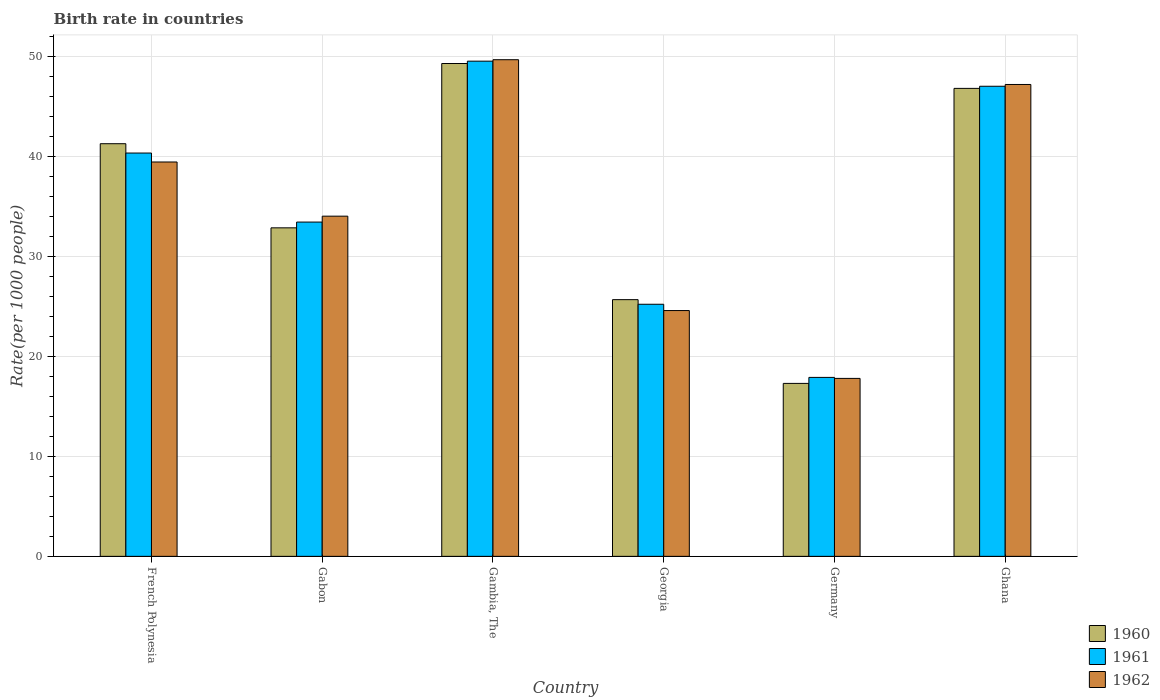How many different coloured bars are there?
Ensure brevity in your answer.  3. How many groups of bars are there?
Your answer should be very brief. 6. Are the number of bars per tick equal to the number of legend labels?
Offer a very short reply. Yes. How many bars are there on the 3rd tick from the right?
Your answer should be very brief. 3. What is the label of the 2nd group of bars from the left?
Offer a very short reply. Gabon. In how many cases, is the number of bars for a given country not equal to the number of legend labels?
Provide a short and direct response. 0. What is the birth rate in 1961 in Gambia, The?
Make the answer very short. 49.53. Across all countries, what is the maximum birth rate in 1960?
Offer a terse response. 49.3. In which country was the birth rate in 1960 maximum?
Your response must be concise. Gambia, The. In which country was the birth rate in 1961 minimum?
Make the answer very short. Germany. What is the total birth rate in 1962 in the graph?
Give a very brief answer. 212.73. What is the difference between the birth rate in 1961 in French Polynesia and that in Georgia?
Provide a short and direct response. 15.13. What is the difference between the birth rate in 1960 in Georgia and the birth rate in 1961 in Gambia, The?
Your answer should be compact. -23.86. What is the average birth rate in 1962 per country?
Give a very brief answer. 35.46. What is the difference between the birth rate of/in 1960 and birth rate of/in 1962 in Germany?
Keep it short and to the point. -0.5. What is the ratio of the birth rate in 1961 in Gabon to that in Gambia, The?
Offer a terse response. 0.68. What is the difference between the highest and the second highest birth rate in 1962?
Your answer should be very brief. 10.23. What is the difference between the highest and the lowest birth rate in 1962?
Give a very brief answer. 31.88. Is the sum of the birth rate in 1961 in Gambia, The and Georgia greater than the maximum birth rate in 1962 across all countries?
Your response must be concise. Yes. What does the 2nd bar from the left in Gambia, The represents?
Your response must be concise. 1961. Is it the case that in every country, the sum of the birth rate in 1962 and birth rate in 1961 is greater than the birth rate in 1960?
Your answer should be very brief. Yes. Are all the bars in the graph horizontal?
Provide a short and direct response. No. Are the values on the major ticks of Y-axis written in scientific E-notation?
Make the answer very short. No. Does the graph contain grids?
Your response must be concise. Yes. How many legend labels are there?
Give a very brief answer. 3. What is the title of the graph?
Provide a short and direct response. Birth rate in countries. What is the label or title of the Y-axis?
Provide a succinct answer. Rate(per 1000 people). What is the Rate(per 1000 people) of 1960 in French Polynesia?
Your response must be concise. 41.27. What is the Rate(per 1000 people) in 1961 in French Polynesia?
Ensure brevity in your answer.  40.34. What is the Rate(per 1000 people) of 1962 in French Polynesia?
Provide a succinct answer. 39.45. What is the Rate(per 1000 people) of 1960 in Gabon?
Your response must be concise. 32.86. What is the Rate(per 1000 people) of 1961 in Gabon?
Your response must be concise. 33.44. What is the Rate(per 1000 people) in 1962 in Gabon?
Offer a terse response. 34.03. What is the Rate(per 1000 people) in 1960 in Gambia, The?
Provide a short and direct response. 49.3. What is the Rate(per 1000 people) in 1961 in Gambia, The?
Your response must be concise. 49.53. What is the Rate(per 1000 people) of 1962 in Gambia, The?
Your answer should be very brief. 49.68. What is the Rate(per 1000 people) of 1960 in Georgia?
Give a very brief answer. 25.68. What is the Rate(per 1000 people) of 1961 in Georgia?
Give a very brief answer. 25.22. What is the Rate(per 1000 people) of 1962 in Georgia?
Give a very brief answer. 24.59. What is the Rate(per 1000 people) of 1961 in Germany?
Keep it short and to the point. 17.9. What is the Rate(per 1000 people) of 1962 in Germany?
Keep it short and to the point. 17.8. What is the Rate(per 1000 people) of 1960 in Ghana?
Offer a very short reply. 46.81. What is the Rate(per 1000 people) of 1961 in Ghana?
Your answer should be compact. 47.02. What is the Rate(per 1000 people) of 1962 in Ghana?
Offer a terse response. 47.2. Across all countries, what is the maximum Rate(per 1000 people) in 1960?
Provide a short and direct response. 49.3. Across all countries, what is the maximum Rate(per 1000 people) of 1961?
Give a very brief answer. 49.53. Across all countries, what is the maximum Rate(per 1000 people) of 1962?
Give a very brief answer. 49.68. Across all countries, what is the minimum Rate(per 1000 people) of 1961?
Your answer should be very brief. 17.9. What is the total Rate(per 1000 people) of 1960 in the graph?
Keep it short and to the point. 213.22. What is the total Rate(per 1000 people) in 1961 in the graph?
Make the answer very short. 213.45. What is the total Rate(per 1000 people) of 1962 in the graph?
Offer a terse response. 212.73. What is the difference between the Rate(per 1000 people) in 1960 in French Polynesia and that in Gabon?
Provide a short and direct response. 8.41. What is the difference between the Rate(per 1000 people) in 1961 in French Polynesia and that in Gabon?
Ensure brevity in your answer.  6.91. What is the difference between the Rate(per 1000 people) of 1962 in French Polynesia and that in Gabon?
Your answer should be compact. 5.42. What is the difference between the Rate(per 1000 people) in 1960 in French Polynesia and that in Gambia, The?
Your answer should be very brief. -8.02. What is the difference between the Rate(per 1000 people) of 1961 in French Polynesia and that in Gambia, The?
Keep it short and to the point. -9.19. What is the difference between the Rate(per 1000 people) of 1962 in French Polynesia and that in Gambia, The?
Keep it short and to the point. -10.23. What is the difference between the Rate(per 1000 people) in 1960 in French Polynesia and that in Georgia?
Offer a terse response. 15.6. What is the difference between the Rate(per 1000 people) in 1961 in French Polynesia and that in Georgia?
Give a very brief answer. 15.13. What is the difference between the Rate(per 1000 people) in 1962 in French Polynesia and that in Georgia?
Keep it short and to the point. 14.86. What is the difference between the Rate(per 1000 people) of 1960 in French Polynesia and that in Germany?
Make the answer very short. 23.98. What is the difference between the Rate(per 1000 people) in 1961 in French Polynesia and that in Germany?
Offer a terse response. 22.44. What is the difference between the Rate(per 1000 people) in 1962 in French Polynesia and that in Germany?
Offer a very short reply. 21.64. What is the difference between the Rate(per 1000 people) of 1960 in French Polynesia and that in Ghana?
Make the answer very short. -5.53. What is the difference between the Rate(per 1000 people) in 1961 in French Polynesia and that in Ghana?
Keep it short and to the point. -6.68. What is the difference between the Rate(per 1000 people) in 1962 in French Polynesia and that in Ghana?
Your answer should be very brief. -7.75. What is the difference between the Rate(per 1000 people) in 1960 in Gabon and that in Gambia, The?
Your response must be concise. -16.44. What is the difference between the Rate(per 1000 people) in 1961 in Gabon and that in Gambia, The?
Offer a very short reply. -16.09. What is the difference between the Rate(per 1000 people) in 1962 in Gabon and that in Gambia, The?
Keep it short and to the point. -15.65. What is the difference between the Rate(per 1000 people) in 1960 in Gabon and that in Georgia?
Ensure brevity in your answer.  7.18. What is the difference between the Rate(per 1000 people) in 1961 in Gabon and that in Georgia?
Provide a succinct answer. 8.22. What is the difference between the Rate(per 1000 people) of 1962 in Gabon and that in Georgia?
Give a very brief answer. 9.44. What is the difference between the Rate(per 1000 people) in 1960 in Gabon and that in Germany?
Make the answer very short. 15.56. What is the difference between the Rate(per 1000 people) in 1961 in Gabon and that in Germany?
Your answer should be compact. 15.54. What is the difference between the Rate(per 1000 people) of 1962 in Gabon and that in Germany?
Keep it short and to the point. 16.23. What is the difference between the Rate(per 1000 people) in 1960 in Gabon and that in Ghana?
Ensure brevity in your answer.  -13.95. What is the difference between the Rate(per 1000 people) of 1961 in Gabon and that in Ghana?
Ensure brevity in your answer.  -13.59. What is the difference between the Rate(per 1000 people) of 1962 in Gabon and that in Ghana?
Offer a terse response. -13.17. What is the difference between the Rate(per 1000 people) of 1960 in Gambia, The and that in Georgia?
Offer a terse response. 23.62. What is the difference between the Rate(per 1000 people) in 1961 in Gambia, The and that in Georgia?
Your response must be concise. 24.32. What is the difference between the Rate(per 1000 people) of 1962 in Gambia, The and that in Georgia?
Your answer should be very brief. 25.09. What is the difference between the Rate(per 1000 people) of 1960 in Gambia, The and that in Germany?
Keep it short and to the point. 32. What is the difference between the Rate(per 1000 people) of 1961 in Gambia, The and that in Germany?
Make the answer very short. 31.63. What is the difference between the Rate(per 1000 people) in 1962 in Gambia, The and that in Germany?
Keep it short and to the point. 31.88. What is the difference between the Rate(per 1000 people) of 1960 in Gambia, The and that in Ghana?
Your answer should be very brief. 2.49. What is the difference between the Rate(per 1000 people) of 1961 in Gambia, The and that in Ghana?
Offer a very short reply. 2.51. What is the difference between the Rate(per 1000 people) in 1962 in Gambia, The and that in Ghana?
Your answer should be very brief. 2.48. What is the difference between the Rate(per 1000 people) in 1960 in Georgia and that in Germany?
Your answer should be compact. 8.38. What is the difference between the Rate(per 1000 people) in 1961 in Georgia and that in Germany?
Provide a succinct answer. 7.32. What is the difference between the Rate(per 1000 people) in 1962 in Georgia and that in Germany?
Your answer should be compact. 6.79. What is the difference between the Rate(per 1000 people) of 1960 in Georgia and that in Ghana?
Give a very brief answer. -21.13. What is the difference between the Rate(per 1000 people) of 1961 in Georgia and that in Ghana?
Your response must be concise. -21.8. What is the difference between the Rate(per 1000 people) of 1962 in Georgia and that in Ghana?
Offer a terse response. -22.61. What is the difference between the Rate(per 1000 people) in 1960 in Germany and that in Ghana?
Provide a short and direct response. -29.51. What is the difference between the Rate(per 1000 people) in 1961 in Germany and that in Ghana?
Your answer should be very brief. -29.12. What is the difference between the Rate(per 1000 people) in 1962 in Germany and that in Ghana?
Make the answer very short. -29.4. What is the difference between the Rate(per 1000 people) of 1960 in French Polynesia and the Rate(per 1000 people) of 1961 in Gabon?
Offer a very short reply. 7.84. What is the difference between the Rate(per 1000 people) in 1960 in French Polynesia and the Rate(per 1000 people) in 1962 in Gabon?
Your answer should be compact. 7.25. What is the difference between the Rate(per 1000 people) in 1961 in French Polynesia and the Rate(per 1000 people) in 1962 in Gabon?
Your response must be concise. 6.32. What is the difference between the Rate(per 1000 people) of 1960 in French Polynesia and the Rate(per 1000 people) of 1961 in Gambia, The?
Your response must be concise. -8.26. What is the difference between the Rate(per 1000 people) in 1960 in French Polynesia and the Rate(per 1000 people) in 1962 in Gambia, The?
Your answer should be compact. -8.4. What is the difference between the Rate(per 1000 people) of 1961 in French Polynesia and the Rate(per 1000 people) of 1962 in Gambia, The?
Your response must be concise. -9.34. What is the difference between the Rate(per 1000 people) in 1960 in French Polynesia and the Rate(per 1000 people) in 1961 in Georgia?
Make the answer very short. 16.06. What is the difference between the Rate(per 1000 people) of 1960 in French Polynesia and the Rate(per 1000 people) of 1962 in Georgia?
Offer a terse response. 16.69. What is the difference between the Rate(per 1000 people) in 1961 in French Polynesia and the Rate(per 1000 people) in 1962 in Georgia?
Keep it short and to the point. 15.76. What is the difference between the Rate(per 1000 people) in 1960 in French Polynesia and the Rate(per 1000 people) in 1961 in Germany?
Offer a very short reply. 23.38. What is the difference between the Rate(per 1000 people) of 1960 in French Polynesia and the Rate(per 1000 people) of 1962 in Germany?
Ensure brevity in your answer.  23.48. What is the difference between the Rate(per 1000 people) in 1961 in French Polynesia and the Rate(per 1000 people) in 1962 in Germany?
Offer a very short reply. 22.54. What is the difference between the Rate(per 1000 people) in 1960 in French Polynesia and the Rate(per 1000 people) in 1961 in Ghana?
Your answer should be compact. -5.75. What is the difference between the Rate(per 1000 people) in 1960 in French Polynesia and the Rate(per 1000 people) in 1962 in Ghana?
Offer a terse response. -5.92. What is the difference between the Rate(per 1000 people) of 1961 in French Polynesia and the Rate(per 1000 people) of 1962 in Ghana?
Your answer should be very brief. -6.86. What is the difference between the Rate(per 1000 people) of 1960 in Gabon and the Rate(per 1000 people) of 1961 in Gambia, The?
Ensure brevity in your answer.  -16.67. What is the difference between the Rate(per 1000 people) of 1960 in Gabon and the Rate(per 1000 people) of 1962 in Gambia, The?
Provide a short and direct response. -16.82. What is the difference between the Rate(per 1000 people) of 1961 in Gabon and the Rate(per 1000 people) of 1962 in Gambia, The?
Give a very brief answer. -16.24. What is the difference between the Rate(per 1000 people) of 1960 in Gabon and the Rate(per 1000 people) of 1961 in Georgia?
Your response must be concise. 7.64. What is the difference between the Rate(per 1000 people) in 1960 in Gabon and the Rate(per 1000 people) in 1962 in Georgia?
Offer a terse response. 8.27. What is the difference between the Rate(per 1000 people) of 1961 in Gabon and the Rate(per 1000 people) of 1962 in Georgia?
Keep it short and to the point. 8.85. What is the difference between the Rate(per 1000 people) of 1960 in Gabon and the Rate(per 1000 people) of 1961 in Germany?
Provide a short and direct response. 14.96. What is the difference between the Rate(per 1000 people) of 1960 in Gabon and the Rate(per 1000 people) of 1962 in Germany?
Your response must be concise. 15.06. What is the difference between the Rate(per 1000 people) of 1961 in Gabon and the Rate(per 1000 people) of 1962 in Germany?
Your response must be concise. 15.64. What is the difference between the Rate(per 1000 people) in 1960 in Gabon and the Rate(per 1000 people) in 1961 in Ghana?
Give a very brief answer. -14.16. What is the difference between the Rate(per 1000 people) in 1960 in Gabon and the Rate(per 1000 people) in 1962 in Ghana?
Your response must be concise. -14.34. What is the difference between the Rate(per 1000 people) in 1961 in Gabon and the Rate(per 1000 people) in 1962 in Ghana?
Give a very brief answer. -13.76. What is the difference between the Rate(per 1000 people) in 1960 in Gambia, The and the Rate(per 1000 people) in 1961 in Georgia?
Your answer should be very brief. 24.08. What is the difference between the Rate(per 1000 people) of 1960 in Gambia, The and the Rate(per 1000 people) of 1962 in Georgia?
Keep it short and to the point. 24.71. What is the difference between the Rate(per 1000 people) in 1961 in Gambia, The and the Rate(per 1000 people) in 1962 in Georgia?
Provide a short and direct response. 24.95. What is the difference between the Rate(per 1000 people) in 1960 in Gambia, The and the Rate(per 1000 people) in 1961 in Germany?
Provide a short and direct response. 31.4. What is the difference between the Rate(per 1000 people) in 1960 in Gambia, The and the Rate(per 1000 people) in 1962 in Germany?
Provide a succinct answer. 31.5. What is the difference between the Rate(per 1000 people) in 1961 in Gambia, The and the Rate(per 1000 people) in 1962 in Germany?
Ensure brevity in your answer.  31.73. What is the difference between the Rate(per 1000 people) in 1960 in Gambia, The and the Rate(per 1000 people) in 1961 in Ghana?
Provide a succinct answer. 2.28. What is the difference between the Rate(per 1000 people) in 1960 in Gambia, The and the Rate(per 1000 people) in 1962 in Ghana?
Keep it short and to the point. 2.1. What is the difference between the Rate(per 1000 people) of 1961 in Gambia, The and the Rate(per 1000 people) of 1962 in Ghana?
Provide a short and direct response. 2.33. What is the difference between the Rate(per 1000 people) in 1960 in Georgia and the Rate(per 1000 people) in 1961 in Germany?
Keep it short and to the point. 7.78. What is the difference between the Rate(per 1000 people) of 1960 in Georgia and the Rate(per 1000 people) of 1962 in Germany?
Ensure brevity in your answer.  7.88. What is the difference between the Rate(per 1000 people) in 1961 in Georgia and the Rate(per 1000 people) in 1962 in Germany?
Your response must be concise. 7.42. What is the difference between the Rate(per 1000 people) of 1960 in Georgia and the Rate(per 1000 people) of 1961 in Ghana?
Offer a terse response. -21.34. What is the difference between the Rate(per 1000 people) in 1960 in Georgia and the Rate(per 1000 people) in 1962 in Ghana?
Ensure brevity in your answer.  -21.52. What is the difference between the Rate(per 1000 people) of 1961 in Georgia and the Rate(per 1000 people) of 1962 in Ghana?
Provide a short and direct response. -21.98. What is the difference between the Rate(per 1000 people) of 1960 in Germany and the Rate(per 1000 people) of 1961 in Ghana?
Provide a succinct answer. -29.72. What is the difference between the Rate(per 1000 people) of 1960 in Germany and the Rate(per 1000 people) of 1962 in Ghana?
Your answer should be very brief. -29.9. What is the difference between the Rate(per 1000 people) of 1961 in Germany and the Rate(per 1000 people) of 1962 in Ghana?
Offer a very short reply. -29.3. What is the average Rate(per 1000 people) of 1960 per country?
Offer a very short reply. 35.54. What is the average Rate(per 1000 people) of 1961 per country?
Keep it short and to the point. 35.57. What is the average Rate(per 1000 people) of 1962 per country?
Provide a short and direct response. 35.46. What is the difference between the Rate(per 1000 people) in 1960 and Rate(per 1000 people) in 1961 in French Polynesia?
Provide a short and direct response. 0.93. What is the difference between the Rate(per 1000 people) in 1960 and Rate(per 1000 people) in 1962 in French Polynesia?
Provide a succinct answer. 1.83. What is the difference between the Rate(per 1000 people) of 1961 and Rate(per 1000 people) of 1962 in French Polynesia?
Make the answer very short. 0.9. What is the difference between the Rate(per 1000 people) of 1960 and Rate(per 1000 people) of 1961 in Gabon?
Your answer should be compact. -0.58. What is the difference between the Rate(per 1000 people) in 1960 and Rate(per 1000 people) in 1962 in Gabon?
Your answer should be compact. -1.17. What is the difference between the Rate(per 1000 people) in 1961 and Rate(per 1000 people) in 1962 in Gabon?
Your answer should be very brief. -0.59. What is the difference between the Rate(per 1000 people) in 1960 and Rate(per 1000 people) in 1961 in Gambia, The?
Keep it short and to the point. -0.23. What is the difference between the Rate(per 1000 people) of 1960 and Rate(per 1000 people) of 1962 in Gambia, The?
Make the answer very short. -0.38. What is the difference between the Rate(per 1000 people) of 1961 and Rate(per 1000 people) of 1962 in Gambia, The?
Make the answer very short. -0.15. What is the difference between the Rate(per 1000 people) of 1960 and Rate(per 1000 people) of 1961 in Georgia?
Your answer should be very brief. 0.46. What is the difference between the Rate(per 1000 people) of 1960 and Rate(per 1000 people) of 1962 in Georgia?
Give a very brief answer. 1.09. What is the difference between the Rate(per 1000 people) of 1961 and Rate(per 1000 people) of 1962 in Georgia?
Give a very brief answer. 0.63. What is the difference between the Rate(per 1000 people) of 1960 and Rate(per 1000 people) of 1961 in Germany?
Offer a terse response. -0.6. What is the difference between the Rate(per 1000 people) in 1960 and Rate(per 1000 people) in 1962 in Germany?
Give a very brief answer. -0.5. What is the difference between the Rate(per 1000 people) of 1960 and Rate(per 1000 people) of 1961 in Ghana?
Offer a terse response. -0.21. What is the difference between the Rate(per 1000 people) of 1960 and Rate(per 1000 people) of 1962 in Ghana?
Offer a very short reply. -0.39. What is the difference between the Rate(per 1000 people) of 1961 and Rate(per 1000 people) of 1962 in Ghana?
Your response must be concise. -0.18. What is the ratio of the Rate(per 1000 people) in 1960 in French Polynesia to that in Gabon?
Your answer should be compact. 1.26. What is the ratio of the Rate(per 1000 people) in 1961 in French Polynesia to that in Gabon?
Your response must be concise. 1.21. What is the ratio of the Rate(per 1000 people) of 1962 in French Polynesia to that in Gabon?
Your answer should be compact. 1.16. What is the ratio of the Rate(per 1000 people) in 1960 in French Polynesia to that in Gambia, The?
Provide a short and direct response. 0.84. What is the ratio of the Rate(per 1000 people) of 1961 in French Polynesia to that in Gambia, The?
Provide a short and direct response. 0.81. What is the ratio of the Rate(per 1000 people) of 1962 in French Polynesia to that in Gambia, The?
Your response must be concise. 0.79. What is the ratio of the Rate(per 1000 people) in 1960 in French Polynesia to that in Georgia?
Your answer should be compact. 1.61. What is the ratio of the Rate(per 1000 people) of 1961 in French Polynesia to that in Georgia?
Your answer should be very brief. 1.6. What is the ratio of the Rate(per 1000 people) of 1962 in French Polynesia to that in Georgia?
Give a very brief answer. 1.6. What is the ratio of the Rate(per 1000 people) in 1960 in French Polynesia to that in Germany?
Ensure brevity in your answer.  2.39. What is the ratio of the Rate(per 1000 people) in 1961 in French Polynesia to that in Germany?
Ensure brevity in your answer.  2.25. What is the ratio of the Rate(per 1000 people) in 1962 in French Polynesia to that in Germany?
Ensure brevity in your answer.  2.22. What is the ratio of the Rate(per 1000 people) of 1960 in French Polynesia to that in Ghana?
Keep it short and to the point. 0.88. What is the ratio of the Rate(per 1000 people) in 1961 in French Polynesia to that in Ghana?
Your response must be concise. 0.86. What is the ratio of the Rate(per 1000 people) in 1962 in French Polynesia to that in Ghana?
Your response must be concise. 0.84. What is the ratio of the Rate(per 1000 people) of 1960 in Gabon to that in Gambia, The?
Offer a terse response. 0.67. What is the ratio of the Rate(per 1000 people) of 1961 in Gabon to that in Gambia, The?
Your answer should be compact. 0.68. What is the ratio of the Rate(per 1000 people) of 1962 in Gabon to that in Gambia, The?
Ensure brevity in your answer.  0.69. What is the ratio of the Rate(per 1000 people) in 1960 in Gabon to that in Georgia?
Keep it short and to the point. 1.28. What is the ratio of the Rate(per 1000 people) in 1961 in Gabon to that in Georgia?
Your answer should be compact. 1.33. What is the ratio of the Rate(per 1000 people) in 1962 in Gabon to that in Georgia?
Offer a very short reply. 1.38. What is the ratio of the Rate(per 1000 people) of 1960 in Gabon to that in Germany?
Ensure brevity in your answer.  1.9. What is the ratio of the Rate(per 1000 people) in 1961 in Gabon to that in Germany?
Your answer should be very brief. 1.87. What is the ratio of the Rate(per 1000 people) in 1962 in Gabon to that in Germany?
Provide a short and direct response. 1.91. What is the ratio of the Rate(per 1000 people) in 1960 in Gabon to that in Ghana?
Your answer should be compact. 0.7. What is the ratio of the Rate(per 1000 people) in 1961 in Gabon to that in Ghana?
Ensure brevity in your answer.  0.71. What is the ratio of the Rate(per 1000 people) of 1962 in Gabon to that in Ghana?
Keep it short and to the point. 0.72. What is the ratio of the Rate(per 1000 people) in 1960 in Gambia, The to that in Georgia?
Your response must be concise. 1.92. What is the ratio of the Rate(per 1000 people) of 1961 in Gambia, The to that in Georgia?
Your response must be concise. 1.96. What is the ratio of the Rate(per 1000 people) of 1962 in Gambia, The to that in Georgia?
Offer a terse response. 2.02. What is the ratio of the Rate(per 1000 people) in 1960 in Gambia, The to that in Germany?
Keep it short and to the point. 2.85. What is the ratio of the Rate(per 1000 people) in 1961 in Gambia, The to that in Germany?
Make the answer very short. 2.77. What is the ratio of the Rate(per 1000 people) in 1962 in Gambia, The to that in Germany?
Make the answer very short. 2.79. What is the ratio of the Rate(per 1000 people) of 1960 in Gambia, The to that in Ghana?
Offer a terse response. 1.05. What is the ratio of the Rate(per 1000 people) of 1961 in Gambia, The to that in Ghana?
Make the answer very short. 1.05. What is the ratio of the Rate(per 1000 people) of 1962 in Gambia, The to that in Ghana?
Your answer should be compact. 1.05. What is the ratio of the Rate(per 1000 people) in 1960 in Georgia to that in Germany?
Your answer should be very brief. 1.48. What is the ratio of the Rate(per 1000 people) in 1961 in Georgia to that in Germany?
Ensure brevity in your answer.  1.41. What is the ratio of the Rate(per 1000 people) of 1962 in Georgia to that in Germany?
Provide a succinct answer. 1.38. What is the ratio of the Rate(per 1000 people) in 1960 in Georgia to that in Ghana?
Keep it short and to the point. 0.55. What is the ratio of the Rate(per 1000 people) in 1961 in Georgia to that in Ghana?
Give a very brief answer. 0.54. What is the ratio of the Rate(per 1000 people) of 1962 in Georgia to that in Ghana?
Ensure brevity in your answer.  0.52. What is the ratio of the Rate(per 1000 people) of 1960 in Germany to that in Ghana?
Your response must be concise. 0.37. What is the ratio of the Rate(per 1000 people) in 1961 in Germany to that in Ghana?
Keep it short and to the point. 0.38. What is the ratio of the Rate(per 1000 people) of 1962 in Germany to that in Ghana?
Your response must be concise. 0.38. What is the difference between the highest and the second highest Rate(per 1000 people) of 1960?
Your answer should be compact. 2.49. What is the difference between the highest and the second highest Rate(per 1000 people) of 1961?
Provide a short and direct response. 2.51. What is the difference between the highest and the second highest Rate(per 1000 people) in 1962?
Keep it short and to the point. 2.48. What is the difference between the highest and the lowest Rate(per 1000 people) of 1960?
Your answer should be compact. 32. What is the difference between the highest and the lowest Rate(per 1000 people) in 1961?
Give a very brief answer. 31.63. What is the difference between the highest and the lowest Rate(per 1000 people) of 1962?
Provide a succinct answer. 31.88. 